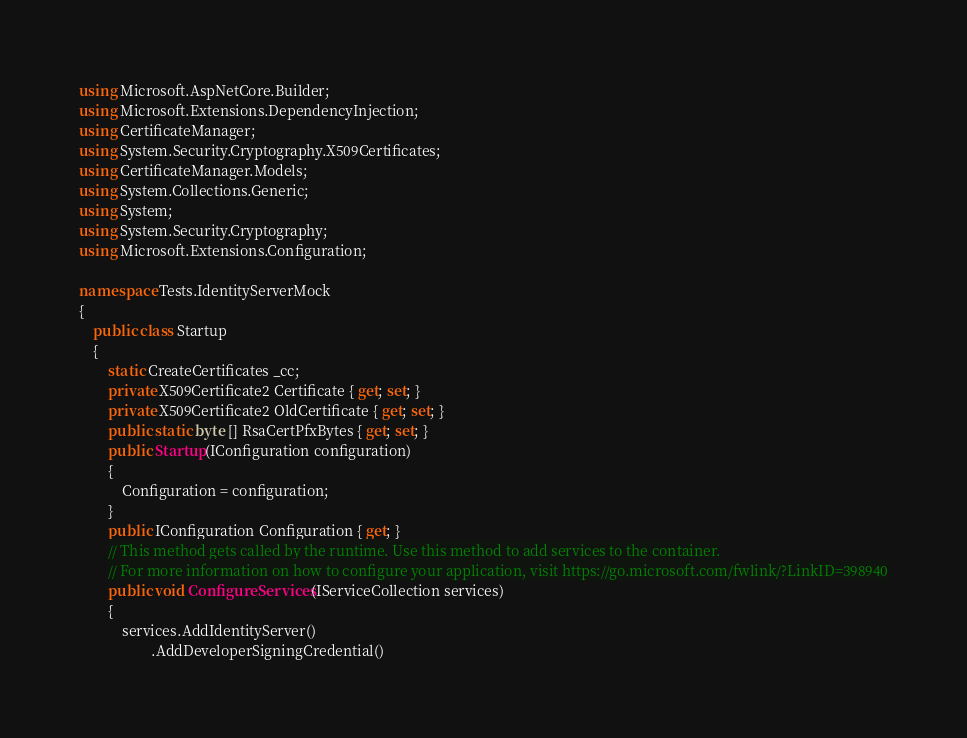<code> <loc_0><loc_0><loc_500><loc_500><_C#_>using Microsoft.AspNetCore.Builder;
using Microsoft.Extensions.DependencyInjection;
using CertificateManager;
using System.Security.Cryptography.X509Certificates;
using CertificateManager.Models;
using System.Collections.Generic;
using System;
using System.Security.Cryptography;
using Microsoft.Extensions.Configuration;

namespace Tests.IdentityServerMock
{
    public class Startup
    {
        static CreateCertificates _cc;
        private X509Certificate2 Certificate { get; set; }
        private X509Certificate2 OldCertificate { get; set; }
        public static byte [] RsaCertPfxBytes { get; set; }
        public Startup(IConfiguration configuration)
        {
            Configuration = configuration;
        }
        public IConfiguration Configuration { get; }
        // This method gets called by the runtime. Use this method to add services to the container.
        // For more information on how to configure your application, visit https://go.microsoft.com/fwlink/?LinkID=398940
        public void ConfigureServices(IServiceCollection services)
        {
            services.AddIdentityServer()
                    .AddDeveloperSigningCredential()</code> 